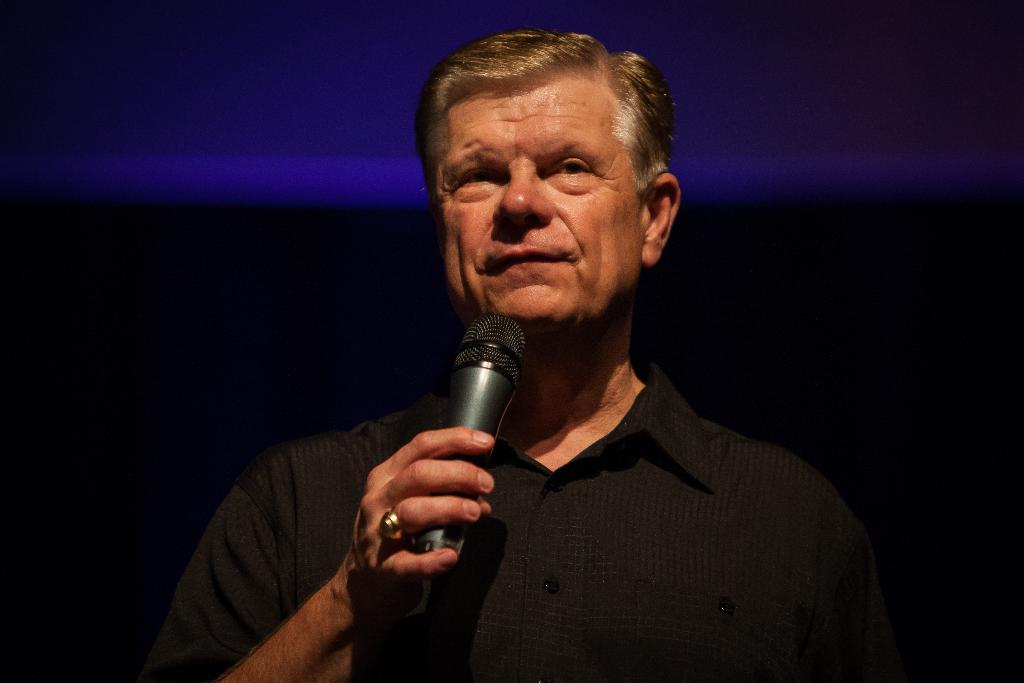Who is the main subject in the image? There is a man in the image. What is the man holding in the image? The man is holding a microphone. What can be observed about the background of the image? The background of the image is dark. What type of paint is being used to create the brick pattern in the image? There is no paint or brick pattern present in the image; it features a man holding a microphone with a dark background. 